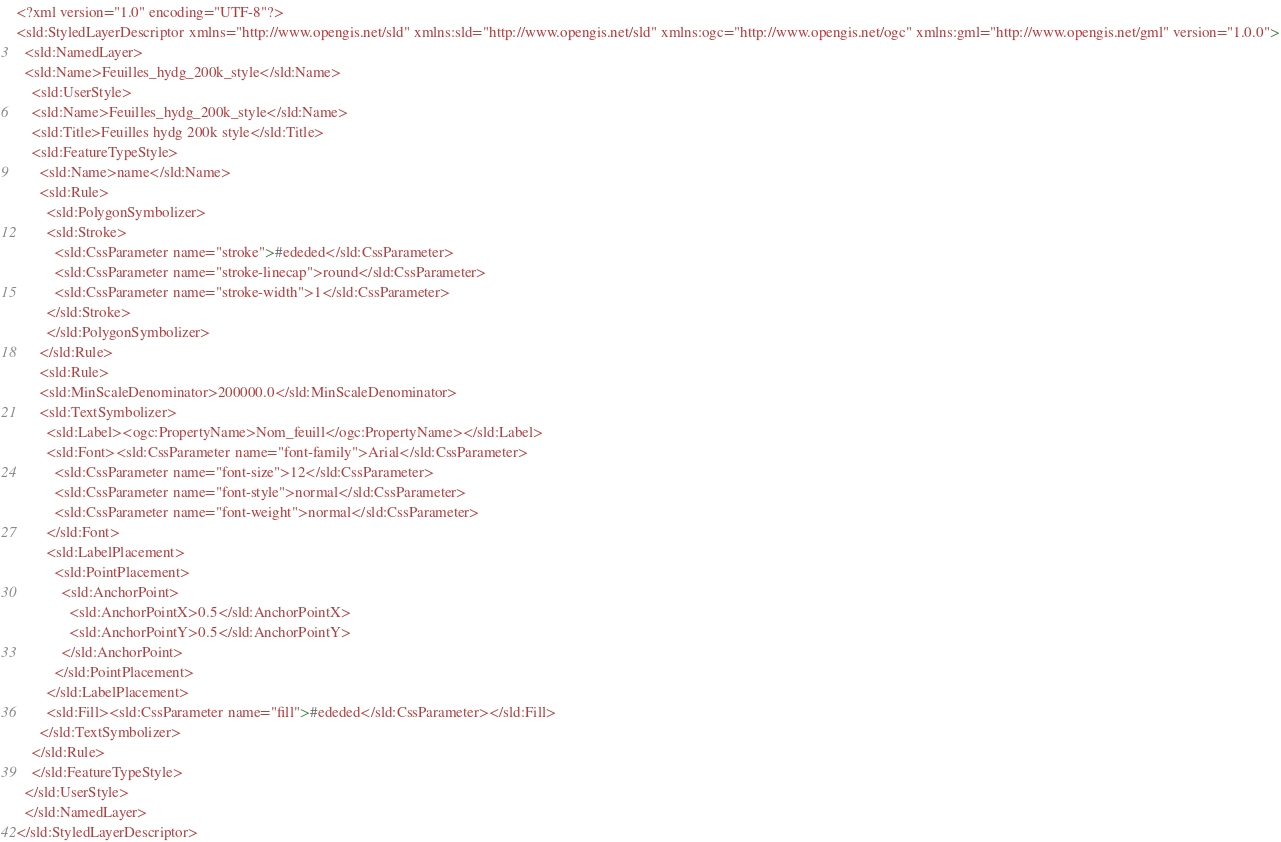Convert code to text. <code><loc_0><loc_0><loc_500><loc_500><_Scheme_><?xml version="1.0" encoding="UTF-8"?>
<sld:StyledLayerDescriptor xmlns="http://www.opengis.net/sld" xmlns:sld="http://www.opengis.net/sld" xmlns:ogc="http://www.opengis.net/ogc" xmlns:gml="http://www.opengis.net/gml" version="1.0.0">
  <sld:NamedLayer>
  <sld:Name>Feuilles_hydg_200k_style</sld:Name>
    <sld:UserStyle>
    <sld:Name>Feuilles_hydg_200k_style</sld:Name>
    <sld:Title>Feuilles hydg 200k style</sld:Title>
    <sld:FeatureTypeStyle>
      <sld:Name>name</sld:Name>
      <sld:Rule>
        <sld:PolygonSymbolizer>
        <sld:Stroke>
          <sld:CssParameter name="stroke">#ededed</sld:CssParameter>
          <sld:CssParameter name="stroke-linecap">round</sld:CssParameter>
          <sld:CssParameter name="stroke-width">1</sld:CssParameter>
        </sld:Stroke>
        </sld:PolygonSymbolizer>
      </sld:Rule>
      <sld:Rule>
      <sld:MinScaleDenominator>200000.0</sld:MinScaleDenominator>
      <sld:TextSymbolizer>
        <sld:Label><ogc:PropertyName>Nom_feuill</ogc:PropertyName></sld:Label>
        <sld:Font><sld:CssParameter name="font-family">Arial</sld:CssParameter>
          <sld:CssParameter name="font-size">12</sld:CssParameter>
          <sld:CssParameter name="font-style">normal</sld:CssParameter>
          <sld:CssParameter name="font-weight">normal</sld:CssParameter>
        </sld:Font>
        <sld:LabelPlacement>
          <sld:PointPlacement>
            <sld:AnchorPoint>
              <sld:AnchorPointX>0.5</sld:AnchorPointX>
              <sld:AnchorPointY>0.5</sld:AnchorPointY>
            </sld:AnchorPoint>
          </sld:PointPlacement>
        </sld:LabelPlacement>
        <sld:Fill><sld:CssParameter name="fill">#ededed</sld:CssParameter></sld:Fill>
      </sld:TextSymbolizer>
    </sld:Rule>
    </sld:FeatureTypeStyle>
  </sld:UserStyle>
  </sld:NamedLayer>
</sld:StyledLayerDescriptor></code> 